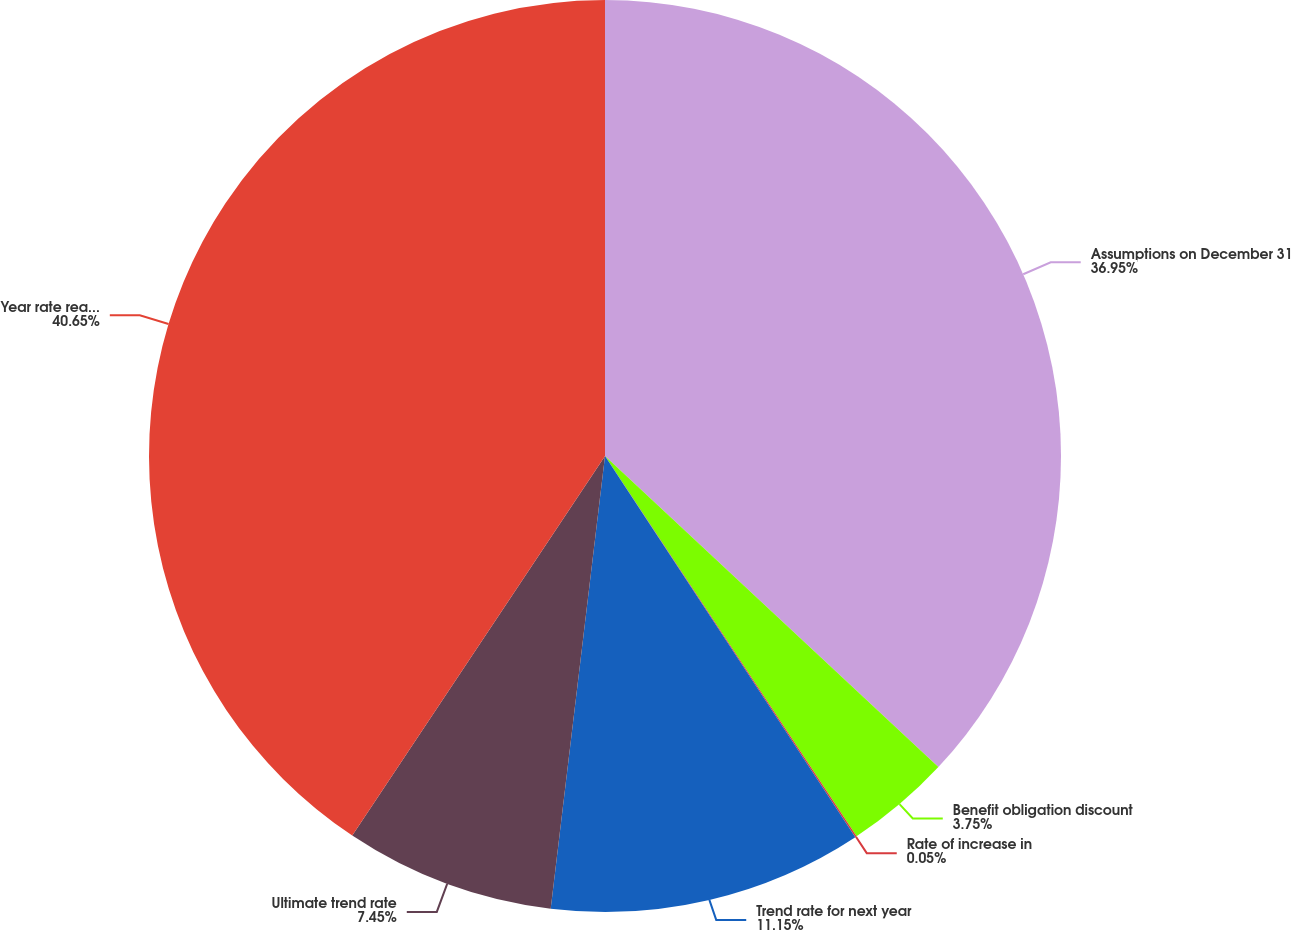Convert chart to OTSL. <chart><loc_0><loc_0><loc_500><loc_500><pie_chart><fcel>Assumptions on December 31<fcel>Benefit obligation discount<fcel>Rate of increase in<fcel>Trend rate for next year<fcel>Ultimate trend rate<fcel>Year rate reaches ultimate<nl><fcel>36.95%<fcel>3.75%<fcel>0.05%<fcel>11.15%<fcel>7.45%<fcel>40.65%<nl></chart> 